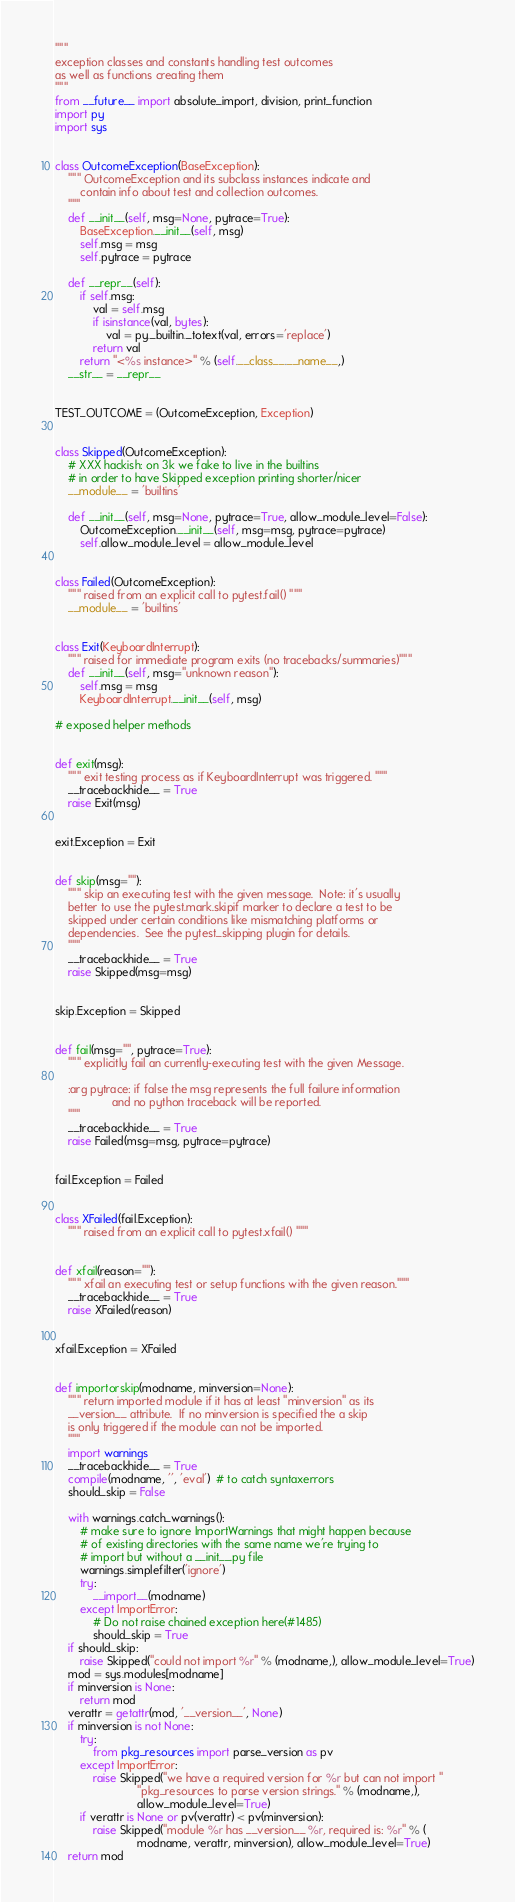<code> <loc_0><loc_0><loc_500><loc_500><_Python_>"""
exception classes and constants handling test outcomes
as well as functions creating them
"""
from __future__ import absolute_import, division, print_function
import py
import sys


class OutcomeException(BaseException):
    """ OutcomeException and its subclass instances indicate and
        contain info about test and collection outcomes.
    """
    def __init__(self, msg=None, pytrace=True):
        BaseException.__init__(self, msg)
        self.msg = msg
        self.pytrace = pytrace

    def __repr__(self):
        if self.msg:
            val = self.msg
            if isinstance(val, bytes):
                val = py._builtin._totext(val, errors='replace')
            return val
        return "<%s instance>" % (self.__class__.__name__,)
    __str__ = __repr__


TEST_OUTCOME = (OutcomeException, Exception)


class Skipped(OutcomeException):
    # XXX hackish: on 3k we fake to live in the builtins
    # in order to have Skipped exception printing shorter/nicer
    __module__ = 'builtins'

    def __init__(self, msg=None, pytrace=True, allow_module_level=False):
        OutcomeException.__init__(self, msg=msg, pytrace=pytrace)
        self.allow_module_level = allow_module_level


class Failed(OutcomeException):
    """ raised from an explicit call to pytest.fail() """
    __module__ = 'builtins'


class Exit(KeyboardInterrupt):
    """ raised for immediate program exits (no tracebacks/summaries)"""
    def __init__(self, msg="unknown reason"):
        self.msg = msg
        KeyboardInterrupt.__init__(self, msg)

# exposed helper methods


def exit(msg):
    """ exit testing process as if KeyboardInterrupt was triggered. """
    __tracebackhide__ = True
    raise Exit(msg)


exit.Exception = Exit


def skip(msg=""):
    """ skip an executing test with the given message.  Note: it's usually
    better to use the pytest.mark.skipif marker to declare a test to be
    skipped under certain conditions like mismatching platforms or
    dependencies.  See the pytest_skipping plugin for details.
    """
    __tracebackhide__ = True
    raise Skipped(msg=msg)


skip.Exception = Skipped


def fail(msg="", pytrace=True):
    """ explicitly fail an currently-executing test with the given Message.

    :arg pytrace: if false the msg represents the full failure information
                  and no python traceback will be reported.
    """
    __tracebackhide__ = True
    raise Failed(msg=msg, pytrace=pytrace)


fail.Exception = Failed


class XFailed(fail.Exception):
    """ raised from an explicit call to pytest.xfail() """


def xfail(reason=""):
    """ xfail an executing test or setup functions with the given reason."""
    __tracebackhide__ = True
    raise XFailed(reason)


xfail.Exception = XFailed


def importorskip(modname, minversion=None):
    """ return imported module if it has at least "minversion" as its
    __version__ attribute.  If no minversion is specified the a skip
    is only triggered if the module can not be imported.
    """
    import warnings
    __tracebackhide__ = True
    compile(modname, '', 'eval')  # to catch syntaxerrors
    should_skip = False

    with warnings.catch_warnings():
        # make sure to ignore ImportWarnings that might happen because
        # of existing directories with the same name we're trying to
        # import but without a __init__.py file
        warnings.simplefilter('ignore')
        try:
            __import__(modname)
        except ImportError:
            # Do not raise chained exception here(#1485)
            should_skip = True
    if should_skip:
        raise Skipped("could not import %r" % (modname,), allow_module_level=True)
    mod = sys.modules[modname]
    if minversion is None:
        return mod
    verattr = getattr(mod, '__version__', None)
    if minversion is not None:
        try:
            from pkg_resources import parse_version as pv
        except ImportError:
            raise Skipped("we have a required version for %r but can not import "
                          "pkg_resources to parse version strings." % (modname,),
                          allow_module_level=True)
        if verattr is None or pv(verattr) < pv(minversion):
            raise Skipped("module %r has __version__ %r, required is: %r" % (
                          modname, verattr, minversion), allow_module_level=True)
    return mod
</code> 